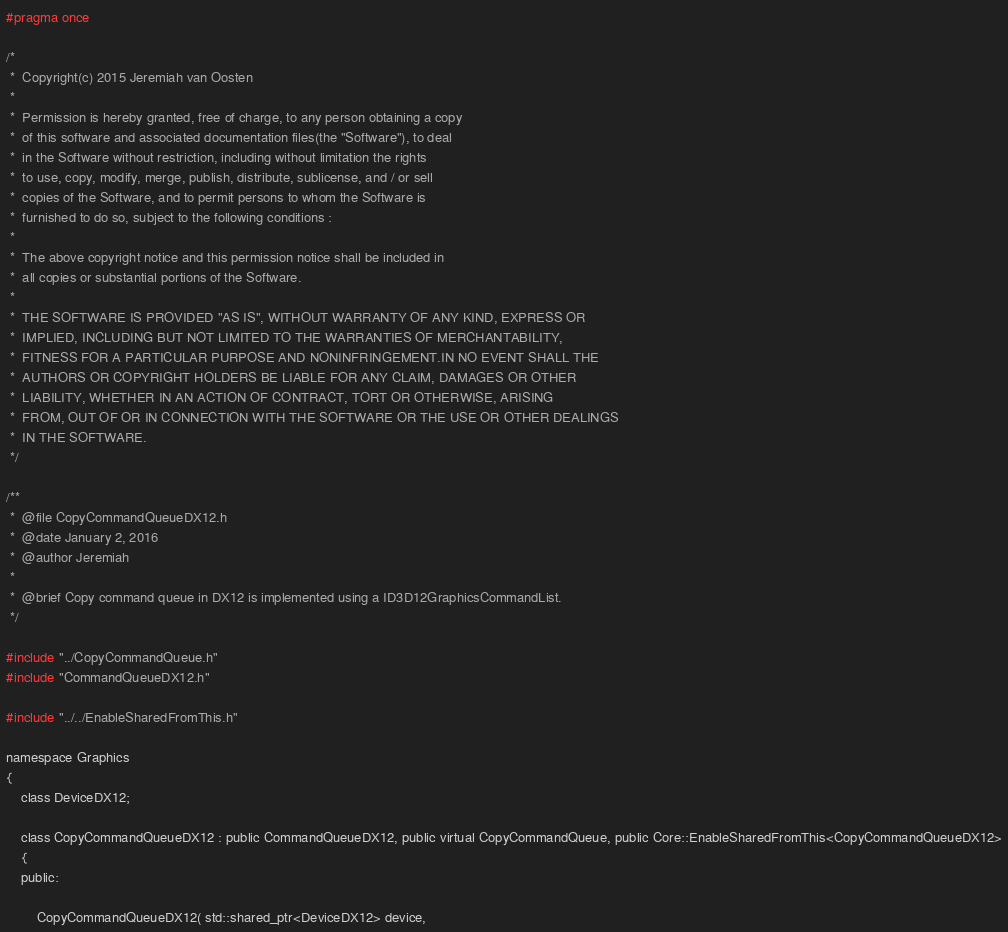<code> <loc_0><loc_0><loc_500><loc_500><_C_>#pragma once

/*
 *  Copyright(c) 2015 Jeremiah van Oosten
 *
 *  Permission is hereby granted, free of charge, to any person obtaining a copy
 *  of this software and associated documentation files(the "Software"), to deal
 *  in the Software without restriction, including without limitation the rights
 *  to use, copy, modify, merge, publish, distribute, sublicense, and / or sell
 *  copies of the Software, and to permit persons to whom the Software is
 *  furnished to do so, subject to the following conditions :
 *
 *  The above copyright notice and this permission notice shall be included in
 *  all copies or substantial portions of the Software.
 *
 *  THE SOFTWARE IS PROVIDED "AS IS", WITHOUT WARRANTY OF ANY KIND, EXPRESS OR
 *  IMPLIED, INCLUDING BUT NOT LIMITED TO THE WARRANTIES OF MERCHANTABILITY,
 *  FITNESS FOR A PARTICULAR PURPOSE AND NONINFRINGEMENT.IN NO EVENT SHALL THE
 *  AUTHORS OR COPYRIGHT HOLDERS BE LIABLE FOR ANY CLAIM, DAMAGES OR OTHER
 *  LIABILITY, WHETHER IN AN ACTION OF CONTRACT, TORT OR OTHERWISE, ARISING
 *  FROM, OUT OF OR IN CONNECTION WITH THE SOFTWARE OR THE USE OR OTHER DEALINGS
 *  IN THE SOFTWARE.
 */

/**
 *  @file CopyCommandQueueDX12.h
 *  @date January 2, 2016
 *  @author Jeremiah
 *
 *  @brief Copy command queue in DX12 is implemented using a ID3D12GraphicsCommandList.
 */

#include "../CopyCommandQueue.h"
#include "CommandQueueDX12.h"

#include "../../EnableSharedFromThis.h"

namespace Graphics
{
    class DeviceDX12;

    class CopyCommandQueueDX12 : public CommandQueueDX12, public virtual CopyCommandQueue, public Core::EnableSharedFromThis<CopyCommandQueueDX12>
    {
    public:

        CopyCommandQueueDX12( std::shared_ptr<DeviceDX12> device,</code> 